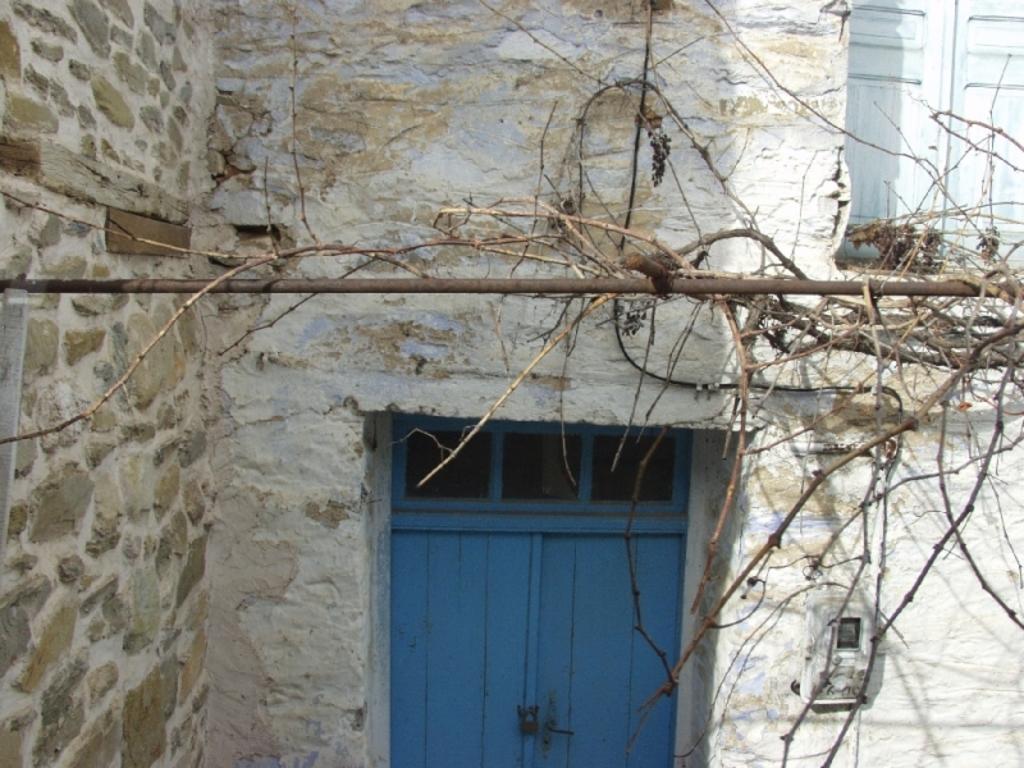How would you summarize this image in a sentence or two? In this image we can see a white color building, there are doors, creepers, pole and a meter board. 